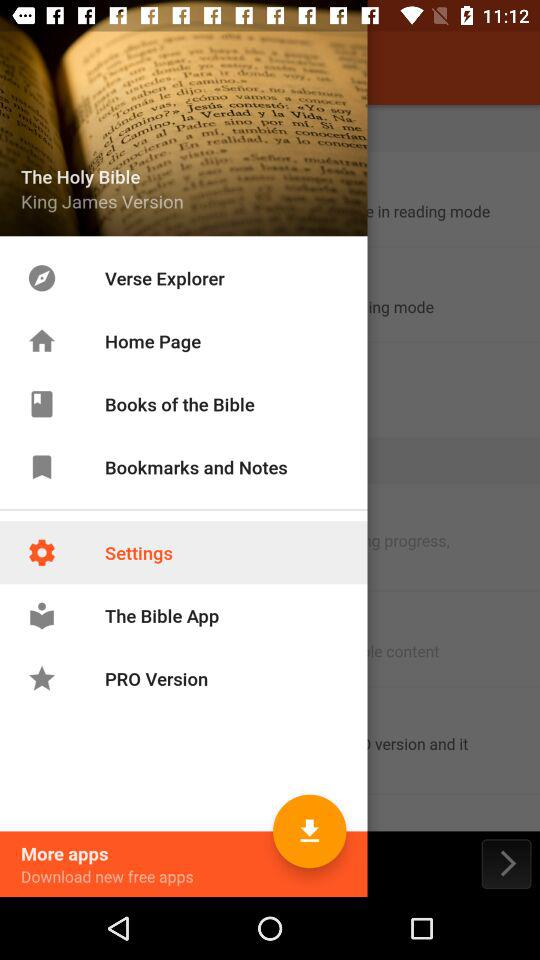What is the selected option? The selected option is "Settings". 